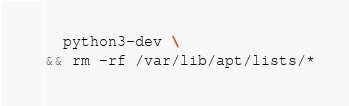Convert code to text. <code><loc_0><loc_0><loc_500><loc_500><_Dockerfile_>  python3-dev \
&& rm -rf /var/lib/apt/lists/*
</code> 